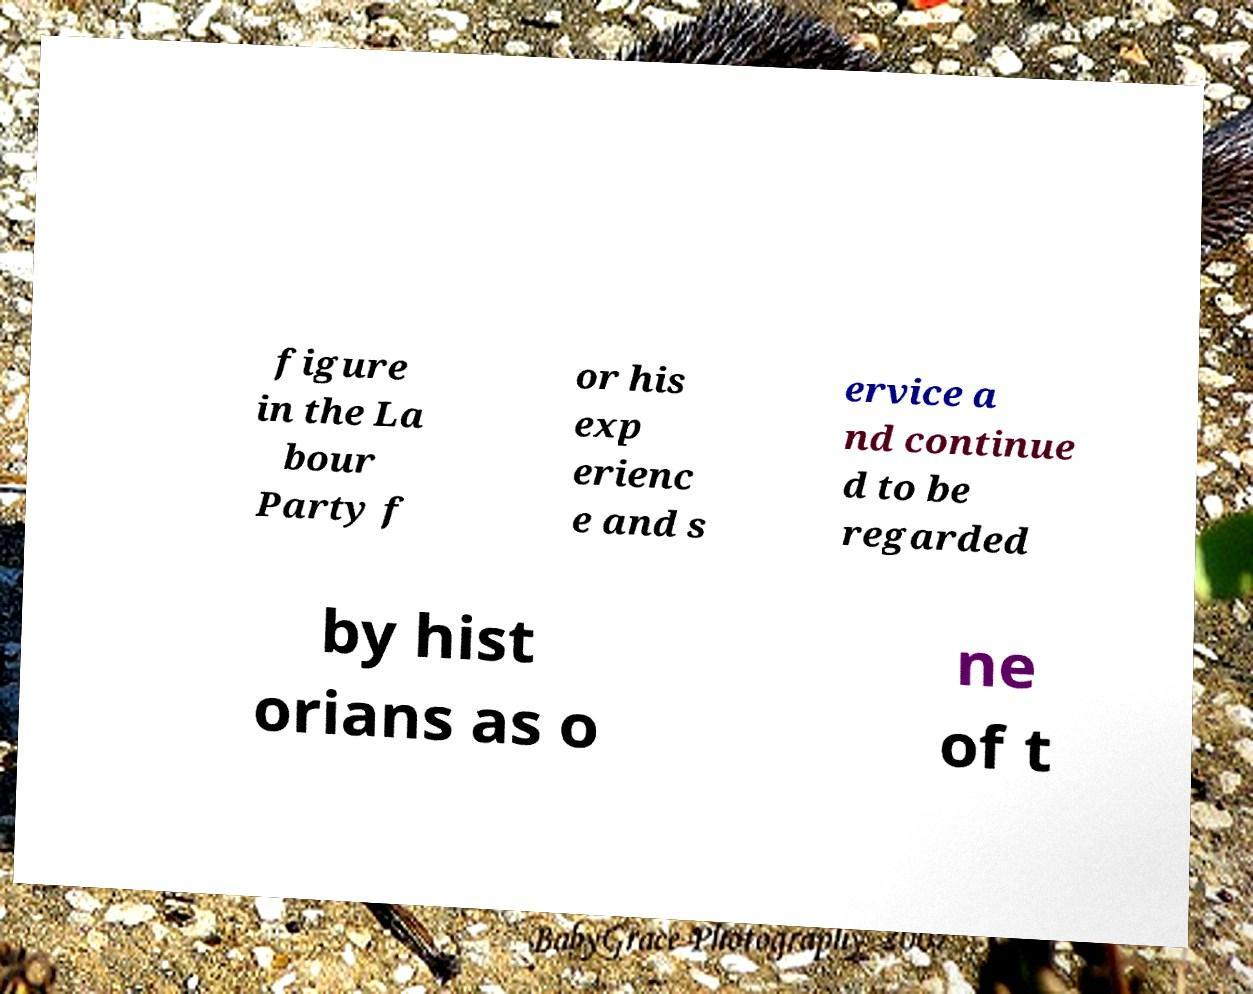There's text embedded in this image that I need extracted. Can you transcribe it verbatim? figure in the La bour Party f or his exp erienc e and s ervice a nd continue d to be regarded by hist orians as o ne of t 